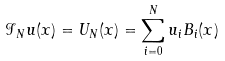<formula> <loc_0><loc_0><loc_500><loc_500>\mathcal { I } _ { N } u ( x ) = U _ { N } ( x ) = \sum _ { i = 0 } ^ { N } u _ { i } B _ { i } ( x )</formula> 